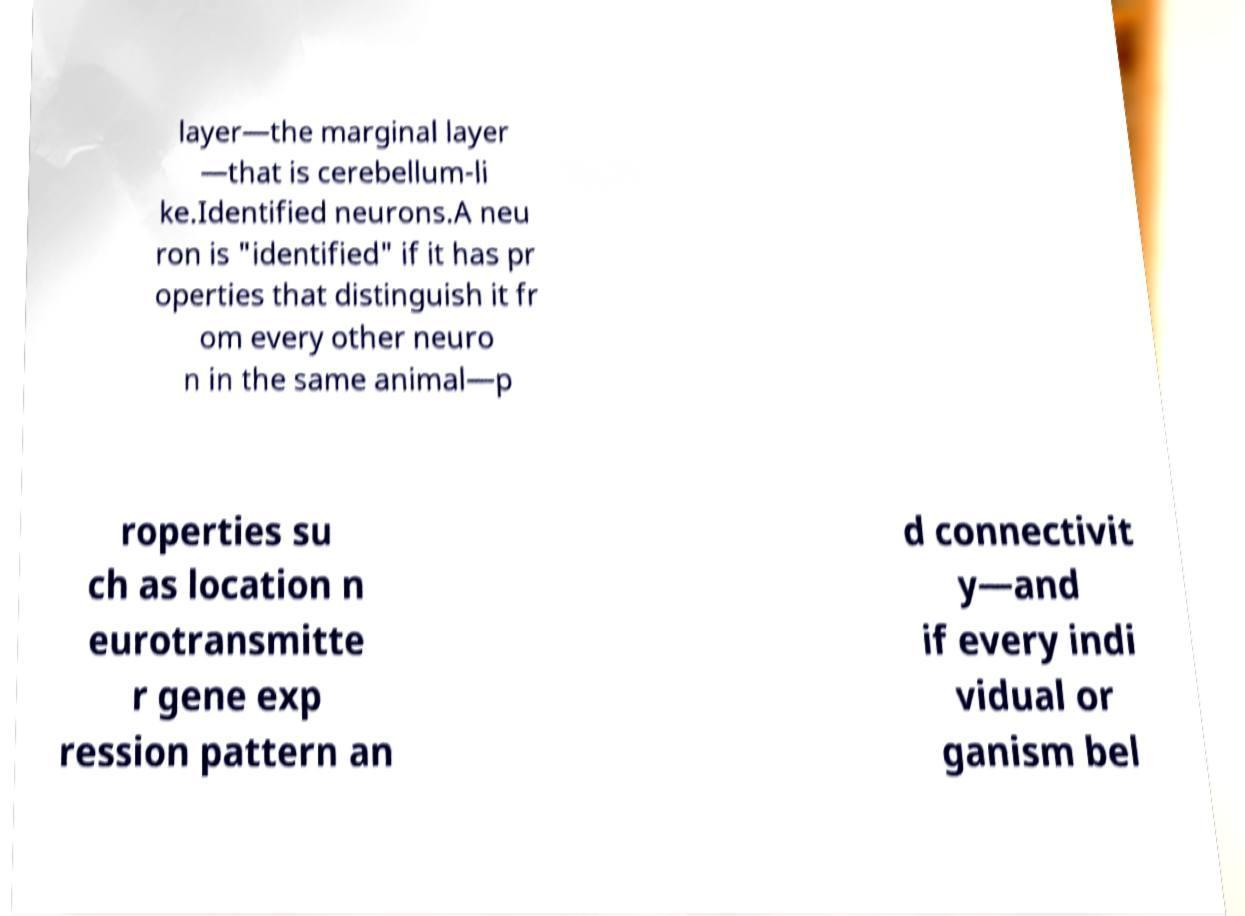Please identify and transcribe the text found in this image. layer—the marginal layer —that is cerebellum-li ke.Identified neurons.A neu ron is "identified" if it has pr operties that distinguish it fr om every other neuro n in the same animal—p roperties su ch as location n eurotransmitte r gene exp ression pattern an d connectivit y—and if every indi vidual or ganism bel 